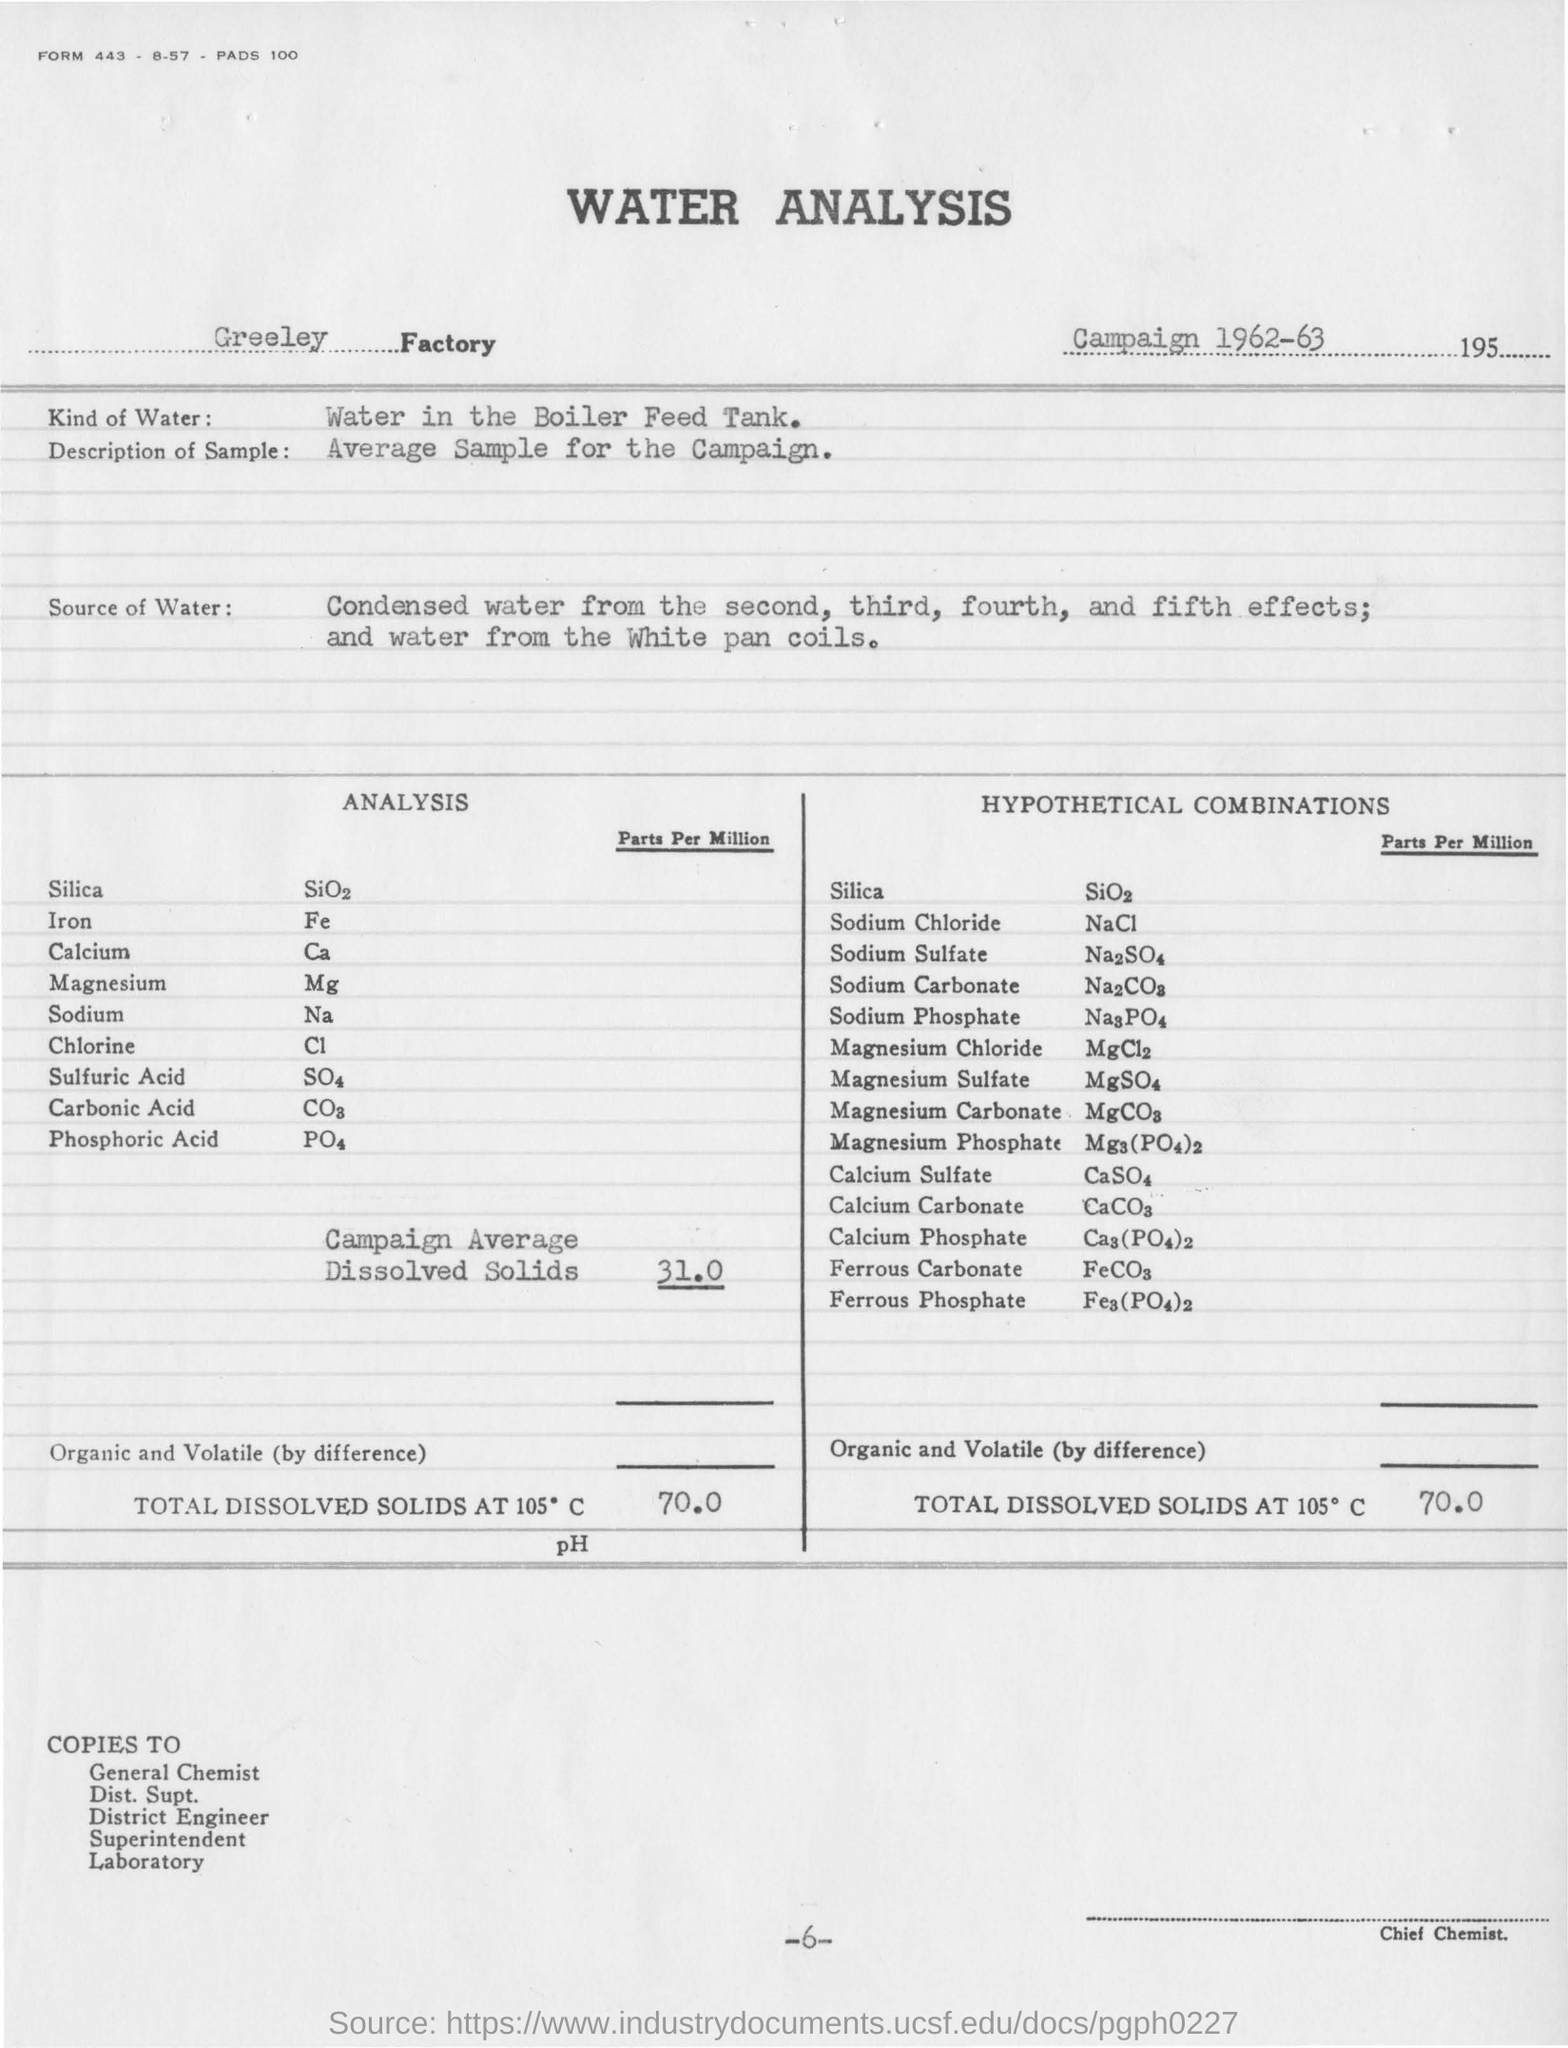What analysis is mentioned in this document?
Offer a very short reply. WATER ANALYSIS. In which Factory is the analysis conducted?
Provide a succinct answer. Greeley Factory. What kind of water is used for analysis?
Your answer should be compact. Water in the Boiler Feed Tank. What is the description of sample taken?
Provide a short and direct response. Average sample for the campaign. What is the value of Campaign Average Dissolved Solids(in Parts per Million)?
Ensure brevity in your answer.  31. What is the page no mentioned in this document?
Your response must be concise. -6-, 6. 